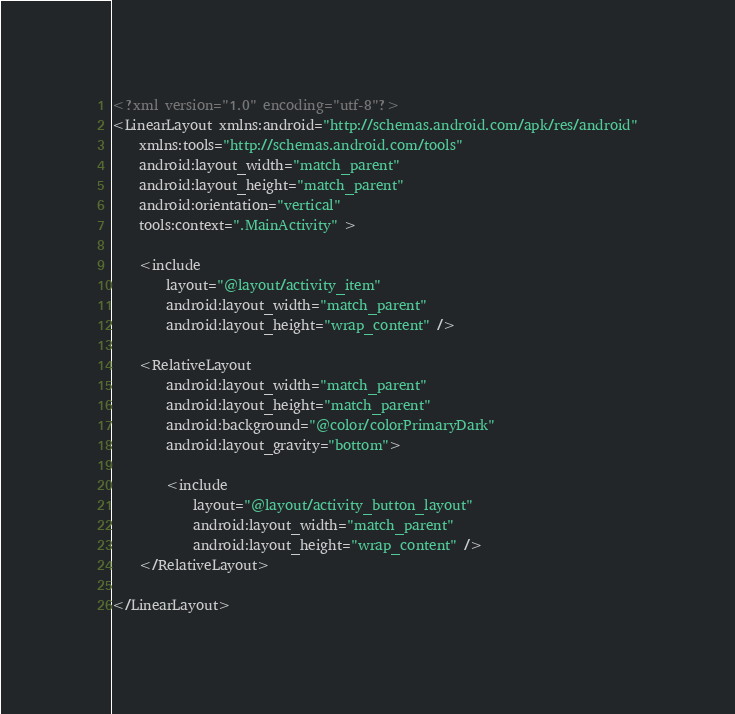Convert code to text. <code><loc_0><loc_0><loc_500><loc_500><_XML_><?xml version="1.0" encoding="utf-8"?>
<LinearLayout xmlns:android="http://schemas.android.com/apk/res/android"
    xmlns:tools="http://schemas.android.com/tools"
    android:layout_width="match_parent"
    android:layout_height="match_parent"
    android:orientation="vertical"
    tools:context=".MainActivity" >

    <include
        layout="@layout/activity_item"
        android:layout_width="match_parent"
        android:layout_height="wrap_content" />

    <RelativeLayout
        android:layout_width="match_parent"
        android:layout_height="match_parent"
        android:background="@color/colorPrimaryDark"
        android:layout_gravity="bottom">

        <include
            layout="@layout/activity_button_layout"
            android:layout_width="match_parent"
            android:layout_height="wrap_content" />
    </RelativeLayout>

</LinearLayout></code> 